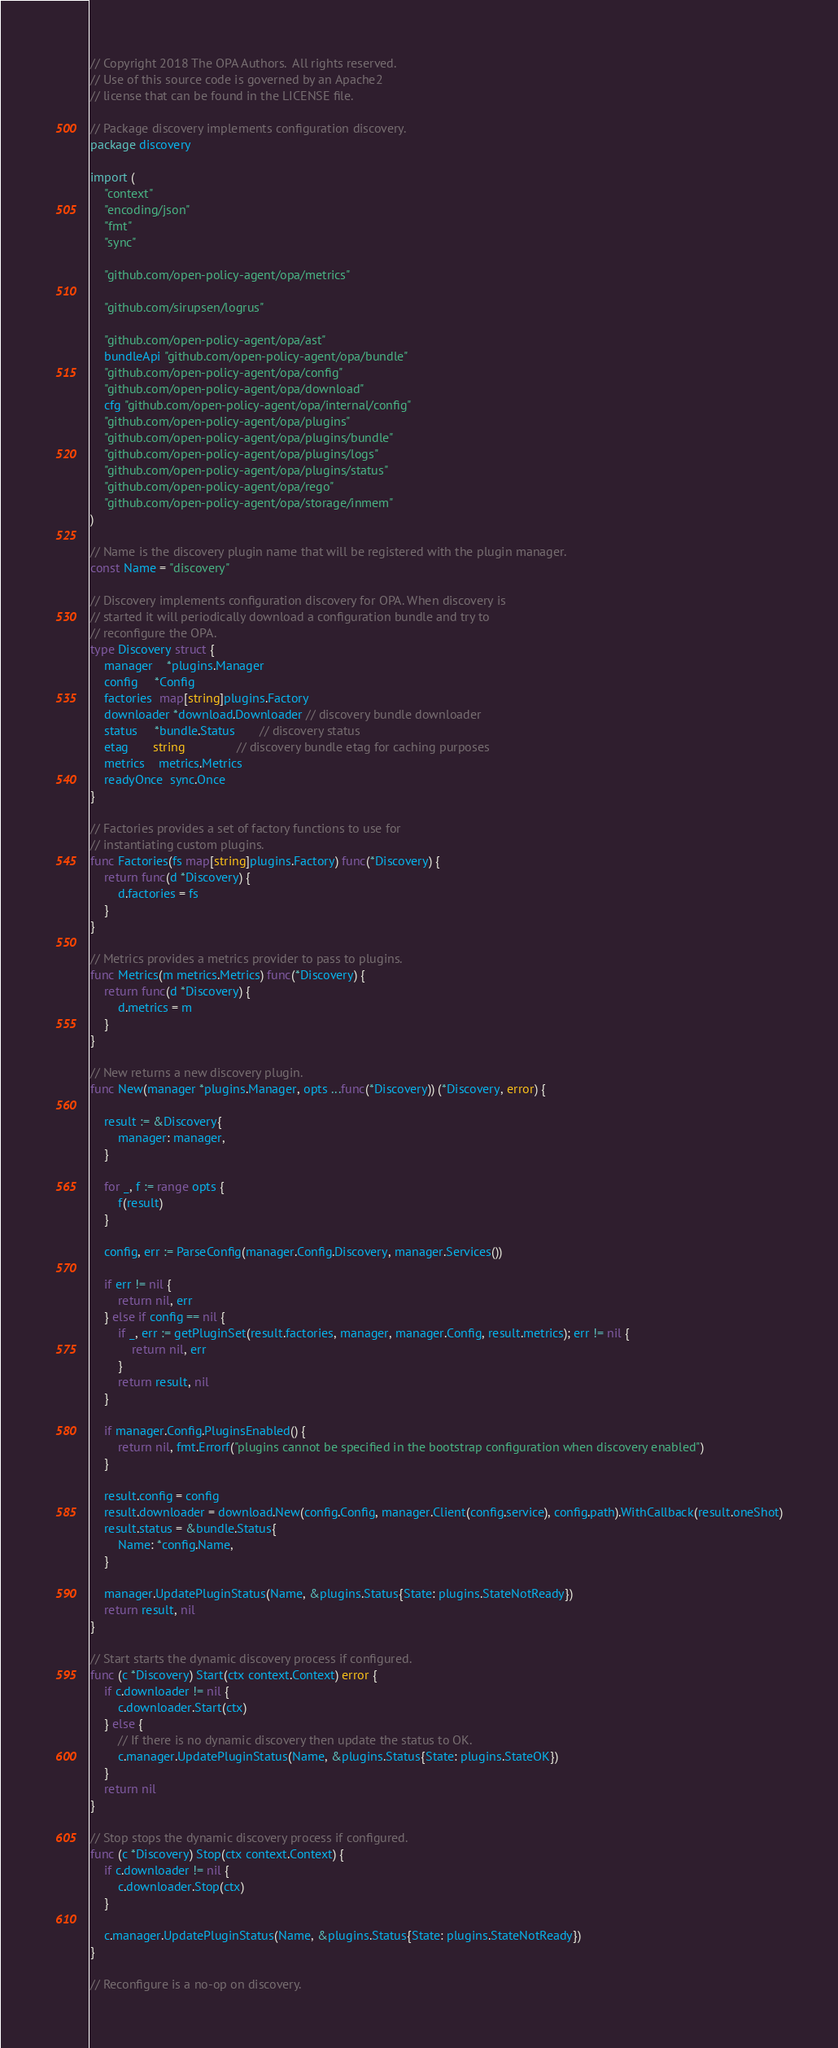<code> <loc_0><loc_0><loc_500><loc_500><_Go_>// Copyright 2018 The OPA Authors.  All rights reserved.
// Use of this source code is governed by an Apache2
// license that can be found in the LICENSE file.

// Package discovery implements configuration discovery.
package discovery

import (
	"context"
	"encoding/json"
	"fmt"
	"sync"

	"github.com/open-policy-agent/opa/metrics"

	"github.com/sirupsen/logrus"

	"github.com/open-policy-agent/opa/ast"
	bundleApi "github.com/open-policy-agent/opa/bundle"
	"github.com/open-policy-agent/opa/config"
	"github.com/open-policy-agent/opa/download"
	cfg "github.com/open-policy-agent/opa/internal/config"
	"github.com/open-policy-agent/opa/plugins"
	"github.com/open-policy-agent/opa/plugins/bundle"
	"github.com/open-policy-agent/opa/plugins/logs"
	"github.com/open-policy-agent/opa/plugins/status"
	"github.com/open-policy-agent/opa/rego"
	"github.com/open-policy-agent/opa/storage/inmem"
)

// Name is the discovery plugin name that will be registered with the plugin manager.
const Name = "discovery"

// Discovery implements configuration discovery for OPA. When discovery is
// started it will periodically download a configuration bundle and try to
// reconfigure the OPA.
type Discovery struct {
	manager    *plugins.Manager
	config     *Config
	factories  map[string]plugins.Factory
	downloader *download.Downloader // discovery bundle downloader
	status     *bundle.Status       // discovery status
	etag       string               // discovery bundle etag for caching purposes
	metrics    metrics.Metrics
	readyOnce  sync.Once
}

// Factories provides a set of factory functions to use for
// instantiating custom plugins.
func Factories(fs map[string]plugins.Factory) func(*Discovery) {
	return func(d *Discovery) {
		d.factories = fs
	}
}

// Metrics provides a metrics provider to pass to plugins.
func Metrics(m metrics.Metrics) func(*Discovery) {
	return func(d *Discovery) {
		d.metrics = m
	}
}

// New returns a new discovery plugin.
func New(manager *plugins.Manager, opts ...func(*Discovery)) (*Discovery, error) {

	result := &Discovery{
		manager: manager,
	}

	for _, f := range opts {
		f(result)
	}

	config, err := ParseConfig(manager.Config.Discovery, manager.Services())

	if err != nil {
		return nil, err
	} else if config == nil {
		if _, err := getPluginSet(result.factories, manager, manager.Config, result.metrics); err != nil {
			return nil, err
		}
		return result, nil
	}

	if manager.Config.PluginsEnabled() {
		return nil, fmt.Errorf("plugins cannot be specified in the bootstrap configuration when discovery enabled")
	}

	result.config = config
	result.downloader = download.New(config.Config, manager.Client(config.service), config.path).WithCallback(result.oneShot)
	result.status = &bundle.Status{
		Name: *config.Name,
	}

	manager.UpdatePluginStatus(Name, &plugins.Status{State: plugins.StateNotReady})
	return result, nil
}

// Start starts the dynamic discovery process if configured.
func (c *Discovery) Start(ctx context.Context) error {
	if c.downloader != nil {
		c.downloader.Start(ctx)
	} else {
		// If there is no dynamic discovery then update the status to OK.
		c.manager.UpdatePluginStatus(Name, &plugins.Status{State: plugins.StateOK})
	}
	return nil
}

// Stop stops the dynamic discovery process if configured.
func (c *Discovery) Stop(ctx context.Context) {
	if c.downloader != nil {
		c.downloader.Stop(ctx)
	}

	c.manager.UpdatePluginStatus(Name, &plugins.Status{State: plugins.StateNotReady})
}

// Reconfigure is a no-op on discovery.</code> 